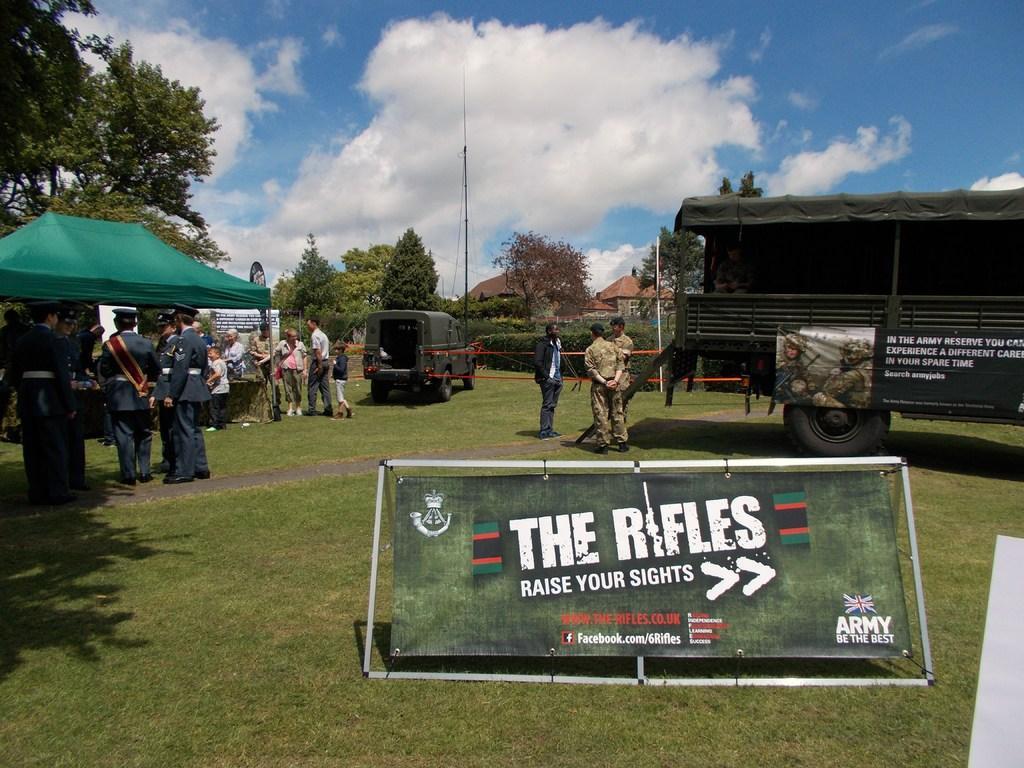Describe this image in one or two sentences. In this image there is a banner tied to the stand which is on the grass, group of people standing, and in the background there are vehicles, pole, tent , table, plants, trees, buildings,sky. 